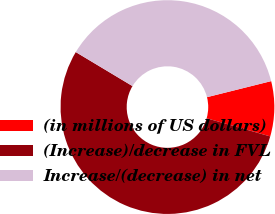Convert chart to OTSL. <chart><loc_0><loc_0><loc_500><loc_500><pie_chart><fcel>(in millions of US dollars)<fcel>(Increase)/decrease in FVL<fcel>Increase/(decrease) in net<nl><fcel>8.33%<fcel>54.17%<fcel>37.5%<nl></chart> 